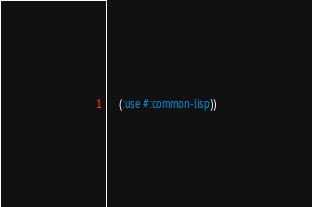<code> <loc_0><loc_0><loc_500><loc_500><_Lisp_>    (:use #:common-lisp))
</code> 